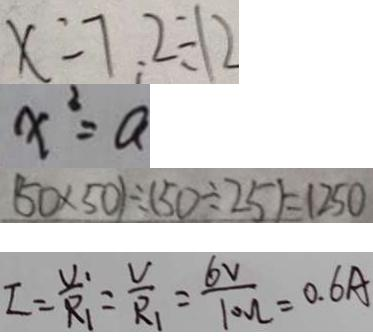Convert formula to latex. <formula><loc_0><loc_0><loc_500><loc_500>x = 7 . 2 \div 1 2 
 x ^ { 2 } = a 
 ( 5 0 \times 5 0 ) \div ( 5 0 \div 2 5 ) = 1 2 5 0 
 I = \frac { V _ { 1 } } { R _ { 1 } } = \frac { V } { R _ { 1 } } = \frac { 6 v } { 1 0 0 l } = 0 . 6 A</formula> 